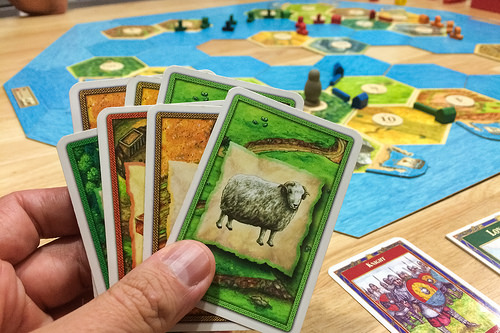<image>
Can you confirm if the card is on the table? No. The card is not positioned on the table. They may be near each other, but the card is not supported by or resting on top of the table. Is there a sheep in front of the card? No. The sheep is not in front of the card. The spatial positioning shows a different relationship between these objects. 